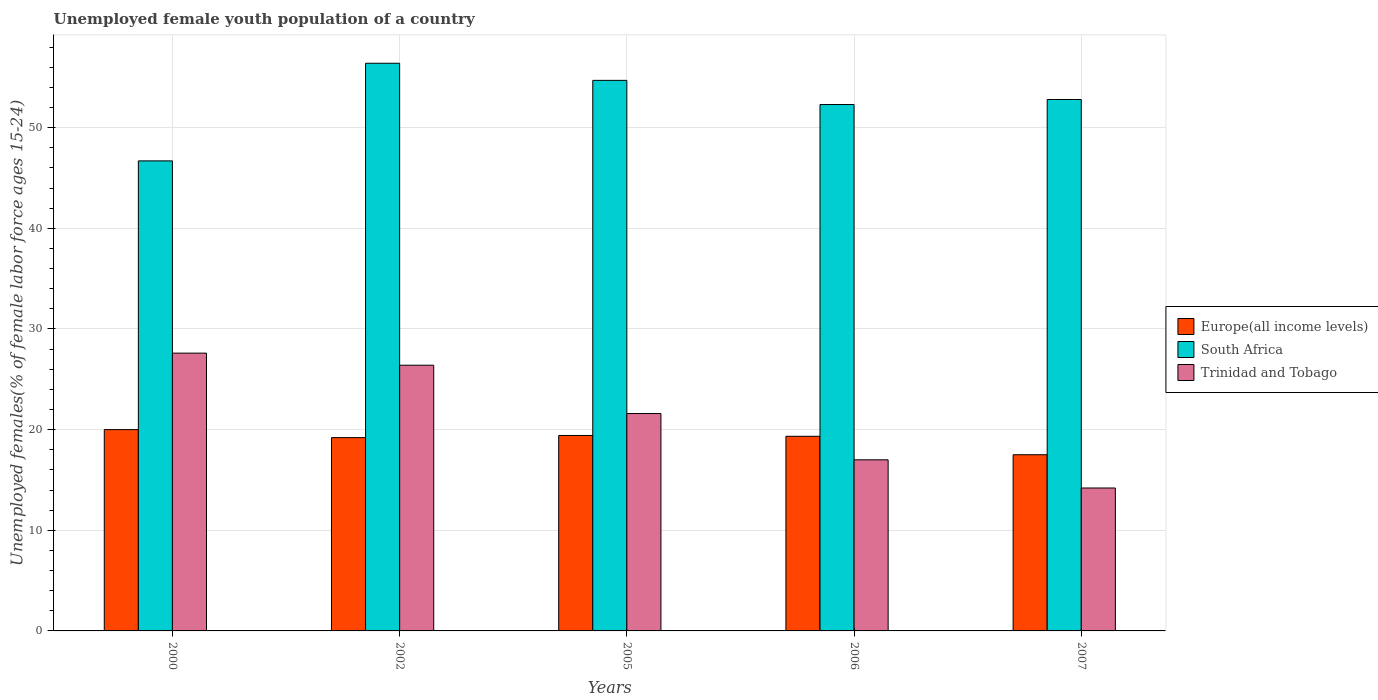What is the label of the 4th group of bars from the left?
Your answer should be compact. 2006. In how many cases, is the number of bars for a given year not equal to the number of legend labels?
Ensure brevity in your answer.  0. What is the percentage of unemployed female youth population in Trinidad and Tobago in 2000?
Keep it short and to the point. 27.6. Across all years, what is the maximum percentage of unemployed female youth population in Trinidad and Tobago?
Keep it short and to the point. 27.6. Across all years, what is the minimum percentage of unemployed female youth population in South Africa?
Offer a terse response. 46.7. In which year was the percentage of unemployed female youth population in Trinidad and Tobago maximum?
Your response must be concise. 2000. In which year was the percentage of unemployed female youth population in Trinidad and Tobago minimum?
Your response must be concise. 2007. What is the total percentage of unemployed female youth population in Trinidad and Tobago in the graph?
Provide a short and direct response. 106.8. What is the difference between the percentage of unemployed female youth population in South Africa in 2000 and that in 2007?
Provide a succinct answer. -6.1. What is the difference between the percentage of unemployed female youth population in South Africa in 2000 and the percentage of unemployed female youth population in Trinidad and Tobago in 2002?
Offer a very short reply. 20.3. What is the average percentage of unemployed female youth population in South Africa per year?
Give a very brief answer. 52.58. In the year 2005, what is the difference between the percentage of unemployed female youth population in Europe(all income levels) and percentage of unemployed female youth population in South Africa?
Give a very brief answer. -35.28. In how many years, is the percentage of unemployed female youth population in Europe(all income levels) greater than 54 %?
Your response must be concise. 0. What is the ratio of the percentage of unemployed female youth population in Europe(all income levels) in 2005 to that in 2006?
Keep it short and to the point. 1. Is the percentage of unemployed female youth population in South Africa in 2002 less than that in 2006?
Make the answer very short. No. What is the difference between the highest and the second highest percentage of unemployed female youth population in South Africa?
Make the answer very short. 1.7. What is the difference between the highest and the lowest percentage of unemployed female youth population in Trinidad and Tobago?
Give a very brief answer. 13.4. In how many years, is the percentage of unemployed female youth population in South Africa greater than the average percentage of unemployed female youth population in South Africa taken over all years?
Your answer should be very brief. 3. Is the sum of the percentage of unemployed female youth population in Trinidad and Tobago in 2000 and 2002 greater than the maximum percentage of unemployed female youth population in South Africa across all years?
Your answer should be very brief. No. What does the 1st bar from the left in 2007 represents?
Provide a short and direct response. Europe(all income levels). What does the 3rd bar from the right in 2007 represents?
Ensure brevity in your answer.  Europe(all income levels). Is it the case that in every year, the sum of the percentage of unemployed female youth population in Trinidad and Tobago and percentage of unemployed female youth population in Europe(all income levels) is greater than the percentage of unemployed female youth population in South Africa?
Keep it short and to the point. No. How many bars are there?
Ensure brevity in your answer.  15. What is the difference between two consecutive major ticks on the Y-axis?
Provide a short and direct response. 10. Are the values on the major ticks of Y-axis written in scientific E-notation?
Keep it short and to the point. No. Does the graph contain any zero values?
Give a very brief answer. No. Where does the legend appear in the graph?
Provide a succinct answer. Center right. How many legend labels are there?
Your answer should be compact. 3. How are the legend labels stacked?
Provide a short and direct response. Vertical. What is the title of the graph?
Your answer should be compact. Unemployed female youth population of a country. Does "Uruguay" appear as one of the legend labels in the graph?
Your answer should be compact. No. What is the label or title of the Y-axis?
Your response must be concise. Unemployed females(% of female labor force ages 15-24). What is the Unemployed females(% of female labor force ages 15-24) in Europe(all income levels) in 2000?
Offer a terse response. 20. What is the Unemployed females(% of female labor force ages 15-24) in South Africa in 2000?
Your answer should be very brief. 46.7. What is the Unemployed females(% of female labor force ages 15-24) in Trinidad and Tobago in 2000?
Ensure brevity in your answer.  27.6. What is the Unemployed females(% of female labor force ages 15-24) of Europe(all income levels) in 2002?
Provide a succinct answer. 19.21. What is the Unemployed females(% of female labor force ages 15-24) of South Africa in 2002?
Keep it short and to the point. 56.4. What is the Unemployed females(% of female labor force ages 15-24) in Trinidad and Tobago in 2002?
Offer a terse response. 26.4. What is the Unemployed females(% of female labor force ages 15-24) of Europe(all income levels) in 2005?
Give a very brief answer. 19.42. What is the Unemployed females(% of female labor force ages 15-24) of South Africa in 2005?
Your answer should be compact. 54.7. What is the Unemployed females(% of female labor force ages 15-24) of Trinidad and Tobago in 2005?
Make the answer very short. 21.6. What is the Unemployed females(% of female labor force ages 15-24) of Europe(all income levels) in 2006?
Offer a terse response. 19.34. What is the Unemployed females(% of female labor force ages 15-24) of South Africa in 2006?
Your answer should be compact. 52.3. What is the Unemployed females(% of female labor force ages 15-24) in Europe(all income levels) in 2007?
Provide a succinct answer. 17.5. What is the Unemployed females(% of female labor force ages 15-24) of South Africa in 2007?
Ensure brevity in your answer.  52.8. What is the Unemployed females(% of female labor force ages 15-24) of Trinidad and Tobago in 2007?
Provide a short and direct response. 14.2. Across all years, what is the maximum Unemployed females(% of female labor force ages 15-24) of Europe(all income levels)?
Offer a very short reply. 20. Across all years, what is the maximum Unemployed females(% of female labor force ages 15-24) in South Africa?
Provide a succinct answer. 56.4. Across all years, what is the maximum Unemployed females(% of female labor force ages 15-24) of Trinidad and Tobago?
Keep it short and to the point. 27.6. Across all years, what is the minimum Unemployed females(% of female labor force ages 15-24) of Europe(all income levels)?
Make the answer very short. 17.5. Across all years, what is the minimum Unemployed females(% of female labor force ages 15-24) of South Africa?
Keep it short and to the point. 46.7. Across all years, what is the minimum Unemployed females(% of female labor force ages 15-24) in Trinidad and Tobago?
Your answer should be very brief. 14.2. What is the total Unemployed females(% of female labor force ages 15-24) in Europe(all income levels) in the graph?
Make the answer very short. 95.47. What is the total Unemployed females(% of female labor force ages 15-24) of South Africa in the graph?
Provide a succinct answer. 262.9. What is the total Unemployed females(% of female labor force ages 15-24) in Trinidad and Tobago in the graph?
Your answer should be compact. 106.8. What is the difference between the Unemployed females(% of female labor force ages 15-24) in Europe(all income levels) in 2000 and that in 2002?
Provide a succinct answer. 0.8. What is the difference between the Unemployed females(% of female labor force ages 15-24) in South Africa in 2000 and that in 2002?
Provide a succinct answer. -9.7. What is the difference between the Unemployed females(% of female labor force ages 15-24) in Europe(all income levels) in 2000 and that in 2005?
Your answer should be very brief. 0.58. What is the difference between the Unemployed females(% of female labor force ages 15-24) in South Africa in 2000 and that in 2005?
Your response must be concise. -8. What is the difference between the Unemployed females(% of female labor force ages 15-24) in Europe(all income levels) in 2000 and that in 2006?
Offer a very short reply. 0.66. What is the difference between the Unemployed females(% of female labor force ages 15-24) of Trinidad and Tobago in 2000 and that in 2006?
Give a very brief answer. 10.6. What is the difference between the Unemployed females(% of female labor force ages 15-24) in Europe(all income levels) in 2000 and that in 2007?
Your answer should be compact. 2.5. What is the difference between the Unemployed females(% of female labor force ages 15-24) of South Africa in 2000 and that in 2007?
Ensure brevity in your answer.  -6.1. What is the difference between the Unemployed females(% of female labor force ages 15-24) in Europe(all income levels) in 2002 and that in 2005?
Provide a succinct answer. -0.21. What is the difference between the Unemployed females(% of female labor force ages 15-24) in South Africa in 2002 and that in 2005?
Give a very brief answer. 1.7. What is the difference between the Unemployed females(% of female labor force ages 15-24) in Trinidad and Tobago in 2002 and that in 2005?
Provide a succinct answer. 4.8. What is the difference between the Unemployed females(% of female labor force ages 15-24) in Europe(all income levels) in 2002 and that in 2006?
Offer a very short reply. -0.13. What is the difference between the Unemployed females(% of female labor force ages 15-24) in Trinidad and Tobago in 2002 and that in 2006?
Provide a succinct answer. 9.4. What is the difference between the Unemployed females(% of female labor force ages 15-24) of Europe(all income levels) in 2002 and that in 2007?
Make the answer very short. 1.7. What is the difference between the Unemployed females(% of female labor force ages 15-24) in Trinidad and Tobago in 2002 and that in 2007?
Keep it short and to the point. 12.2. What is the difference between the Unemployed females(% of female labor force ages 15-24) of Europe(all income levels) in 2005 and that in 2006?
Offer a very short reply. 0.08. What is the difference between the Unemployed females(% of female labor force ages 15-24) in Europe(all income levels) in 2005 and that in 2007?
Offer a terse response. 1.92. What is the difference between the Unemployed females(% of female labor force ages 15-24) in South Africa in 2005 and that in 2007?
Your answer should be compact. 1.9. What is the difference between the Unemployed females(% of female labor force ages 15-24) in Trinidad and Tobago in 2005 and that in 2007?
Give a very brief answer. 7.4. What is the difference between the Unemployed females(% of female labor force ages 15-24) of Europe(all income levels) in 2006 and that in 2007?
Make the answer very short. 1.83. What is the difference between the Unemployed females(% of female labor force ages 15-24) of South Africa in 2006 and that in 2007?
Give a very brief answer. -0.5. What is the difference between the Unemployed females(% of female labor force ages 15-24) of Europe(all income levels) in 2000 and the Unemployed females(% of female labor force ages 15-24) of South Africa in 2002?
Provide a short and direct response. -36.4. What is the difference between the Unemployed females(% of female labor force ages 15-24) in Europe(all income levels) in 2000 and the Unemployed females(% of female labor force ages 15-24) in Trinidad and Tobago in 2002?
Your answer should be compact. -6.4. What is the difference between the Unemployed females(% of female labor force ages 15-24) of South Africa in 2000 and the Unemployed females(% of female labor force ages 15-24) of Trinidad and Tobago in 2002?
Give a very brief answer. 20.3. What is the difference between the Unemployed females(% of female labor force ages 15-24) of Europe(all income levels) in 2000 and the Unemployed females(% of female labor force ages 15-24) of South Africa in 2005?
Offer a very short reply. -34.7. What is the difference between the Unemployed females(% of female labor force ages 15-24) in Europe(all income levels) in 2000 and the Unemployed females(% of female labor force ages 15-24) in Trinidad and Tobago in 2005?
Your response must be concise. -1.6. What is the difference between the Unemployed females(% of female labor force ages 15-24) in South Africa in 2000 and the Unemployed females(% of female labor force ages 15-24) in Trinidad and Tobago in 2005?
Offer a terse response. 25.1. What is the difference between the Unemployed females(% of female labor force ages 15-24) of Europe(all income levels) in 2000 and the Unemployed females(% of female labor force ages 15-24) of South Africa in 2006?
Make the answer very short. -32.3. What is the difference between the Unemployed females(% of female labor force ages 15-24) in Europe(all income levels) in 2000 and the Unemployed females(% of female labor force ages 15-24) in Trinidad and Tobago in 2006?
Provide a short and direct response. 3. What is the difference between the Unemployed females(% of female labor force ages 15-24) in South Africa in 2000 and the Unemployed females(% of female labor force ages 15-24) in Trinidad and Tobago in 2006?
Offer a terse response. 29.7. What is the difference between the Unemployed females(% of female labor force ages 15-24) in Europe(all income levels) in 2000 and the Unemployed females(% of female labor force ages 15-24) in South Africa in 2007?
Make the answer very short. -32.8. What is the difference between the Unemployed females(% of female labor force ages 15-24) in Europe(all income levels) in 2000 and the Unemployed females(% of female labor force ages 15-24) in Trinidad and Tobago in 2007?
Your answer should be very brief. 5.8. What is the difference between the Unemployed females(% of female labor force ages 15-24) of South Africa in 2000 and the Unemployed females(% of female labor force ages 15-24) of Trinidad and Tobago in 2007?
Your response must be concise. 32.5. What is the difference between the Unemployed females(% of female labor force ages 15-24) of Europe(all income levels) in 2002 and the Unemployed females(% of female labor force ages 15-24) of South Africa in 2005?
Keep it short and to the point. -35.49. What is the difference between the Unemployed females(% of female labor force ages 15-24) of Europe(all income levels) in 2002 and the Unemployed females(% of female labor force ages 15-24) of Trinidad and Tobago in 2005?
Your response must be concise. -2.39. What is the difference between the Unemployed females(% of female labor force ages 15-24) of South Africa in 2002 and the Unemployed females(% of female labor force ages 15-24) of Trinidad and Tobago in 2005?
Make the answer very short. 34.8. What is the difference between the Unemployed females(% of female labor force ages 15-24) of Europe(all income levels) in 2002 and the Unemployed females(% of female labor force ages 15-24) of South Africa in 2006?
Ensure brevity in your answer.  -33.09. What is the difference between the Unemployed females(% of female labor force ages 15-24) of Europe(all income levels) in 2002 and the Unemployed females(% of female labor force ages 15-24) of Trinidad and Tobago in 2006?
Your answer should be compact. 2.21. What is the difference between the Unemployed females(% of female labor force ages 15-24) in South Africa in 2002 and the Unemployed females(% of female labor force ages 15-24) in Trinidad and Tobago in 2006?
Make the answer very short. 39.4. What is the difference between the Unemployed females(% of female labor force ages 15-24) in Europe(all income levels) in 2002 and the Unemployed females(% of female labor force ages 15-24) in South Africa in 2007?
Provide a short and direct response. -33.59. What is the difference between the Unemployed females(% of female labor force ages 15-24) of Europe(all income levels) in 2002 and the Unemployed females(% of female labor force ages 15-24) of Trinidad and Tobago in 2007?
Your response must be concise. 5.01. What is the difference between the Unemployed females(% of female labor force ages 15-24) in South Africa in 2002 and the Unemployed females(% of female labor force ages 15-24) in Trinidad and Tobago in 2007?
Provide a succinct answer. 42.2. What is the difference between the Unemployed females(% of female labor force ages 15-24) in Europe(all income levels) in 2005 and the Unemployed females(% of female labor force ages 15-24) in South Africa in 2006?
Your answer should be compact. -32.88. What is the difference between the Unemployed females(% of female labor force ages 15-24) in Europe(all income levels) in 2005 and the Unemployed females(% of female labor force ages 15-24) in Trinidad and Tobago in 2006?
Your answer should be very brief. 2.42. What is the difference between the Unemployed females(% of female labor force ages 15-24) of South Africa in 2005 and the Unemployed females(% of female labor force ages 15-24) of Trinidad and Tobago in 2006?
Offer a very short reply. 37.7. What is the difference between the Unemployed females(% of female labor force ages 15-24) of Europe(all income levels) in 2005 and the Unemployed females(% of female labor force ages 15-24) of South Africa in 2007?
Your answer should be compact. -33.38. What is the difference between the Unemployed females(% of female labor force ages 15-24) in Europe(all income levels) in 2005 and the Unemployed females(% of female labor force ages 15-24) in Trinidad and Tobago in 2007?
Your answer should be compact. 5.22. What is the difference between the Unemployed females(% of female labor force ages 15-24) of South Africa in 2005 and the Unemployed females(% of female labor force ages 15-24) of Trinidad and Tobago in 2007?
Make the answer very short. 40.5. What is the difference between the Unemployed females(% of female labor force ages 15-24) of Europe(all income levels) in 2006 and the Unemployed females(% of female labor force ages 15-24) of South Africa in 2007?
Your response must be concise. -33.46. What is the difference between the Unemployed females(% of female labor force ages 15-24) in Europe(all income levels) in 2006 and the Unemployed females(% of female labor force ages 15-24) in Trinidad and Tobago in 2007?
Your answer should be compact. 5.14. What is the difference between the Unemployed females(% of female labor force ages 15-24) in South Africa in 2006 and the Unemployed females(% of female labor force ages 15-24) in Trinidad and Tobago in 2007?
Offer a very short reply. 38.1. What is the average Unemployed females(% of female labor force ages 15-24) of Europe(all income levels) per year?
Give a very brief answer. 19.09. What is the average Unemployed females(% of female labor force ages 15-24) in South Africa per year?
Your response must be concise. 52.58. What is the average Unemployed females(% of female labor force ages 15-24) of Trinidad and Tobago per year?
Your answer should be compact. 21.36. In the year 2000, what is the difference between the Unemployed females(% of female labor force ages 15-24) in Europe(all income levels) and Unemployed females(% of female labor force ages 15-24) in South Africa?
Ensure brevity in your answer.  -26.7. In the year 2000, what is the difference between the Unemployed females(% of female labor force ages 15-24) of Europe(all income levels) and Unemployed females(% of female labor force ages 15-24) of Trinidad and Tobago?
Offer a terse response. -7.6. In the year 2002, what is the difference between the Unemployed females(% of female labor force ages 15-24) of Europe(all income levels) and Unemployed females(% of female labor force ages 15-24) of South Africa?
Give a very brief answer. -37.19. In the year 2002, what is the difference between the Unemployed females(% of female labor force ages 15-24) of Europe(all income levels) and Unemployed females(% of female labor force ages 15-24) of Trinidad and Tobago?
Keep it short and to the point. -7.19. In the year 2002, what is the difference between the Unemployed females(% of female labor force ages 15-24) of South Africa and Unemployed females(% of female labor force ages 15-24) of Trinidad and Tobago?
Provide a short and direct response. 30. In the year 2005, what is the difference between the Unemployed females(% of female labor force ages 15-24) in Europe(all income levels) and Unemployed females(% of female labor force ages 15-24) in South Africa?
Offer a terse response. -35.28. In the year 2005, what is the difference between the Unemployed females(% of female labor force ages 15-24) of Europe(all income levels) and Unemployed females(% of female labor force ages 15-24) of Trinidad and Tobago?
Keep it short and to the point. -2.18. In the year 2005, what is the difference between the Unemployed females(% of female labor force ages 15-24) of South Africa and Unemployed females(% of female labor force ages 15-24) of Trinidad and Tobago?
Your answer should be compact. 33.1. In the year 2006, what is the difference between the Unemployed females(% of female labor force ages 15-24) in Europe(all income levels) and Unemployed females(% of female labor force ages 15-24) in South Africa?
Offer a very short reply. -32.96. In the year 2006, what is the difference between the Unemployed females(% of female labor force ages 15-24) of Europe(all income levels) and Unemployed females(% of female labor force ages 15-24) of Trinidad and Tobago?
Keep it short and to the point. 2.34. In the year 2006, what is the difference between the Unemployed females(% of female labor force ages 15-24) of South Africa and Unemployed females(% of female labor force ages 15-24) of Trinidad and Tobago?
Your answer should be compact. 35.3. In the year 2007, what is the difference between the Unemployed females(% of female labor force ages 15-24) of Europe(all income levels) and Unemployed females(% of female labor force ages 15-24) of South Africa?
Your response must be concise. -35.3. In the year 2007, what is the difference between the Unemployed females(% of female labor force ages 15-24) in Europe(all income levels) and Unemployed females(% of female labor force ages 15-24) in Trinidad and Tobago?
Give a very brief answer. 3.3. In the year 2007, what is the difference between the Unemployed females(% of female labor force ages 15-24) of South Africa and Unemployed females(% of female labor force ages 15-24) of Trinidad and Tobago?
Give a very brief answer. 38.6. What is the ratio of the Unemployed females(% of female labor force ages 15-24) of Europe(all income levels) in 2000 to that in 2002?
Your answer should be very brief. 1.04. What is the ratio of the Unemployed females(% of female labor force ages 15-24) in South Africa in 2000 to that in 2002?
Provide a short and direct response. 0.83. What is the ratio of the Unemployed females(% of female labor force ages 15-24) in Trinidad and Tobago in 2000 to that in 2002?
Offer a very short reply. 1.05. What is the ratio of the Unemployed females(% of female labor force ages 15-24) in Europe(all income levels) in 2000 to that in 2005?
Offer a terse response. 1.03. What is the ratio of the Unemployed females(% of female labor force ages 15-24) in South Africa in 2000 to that in 2005?
Your response must be concise. 0.85. What is the ratio of the Unemployed females(% of female labor force ages 15-24) in Trinidad and Tobago in 2000 to that in 2005?
Your answer should be very brief. 1.28. What is the ratio of the Unemployed females(% of female labor force ages 15-24) in Europe(all income levels) in 2000 to that in 2006?
Your answer should be very brief. 1.03. What is the ratio of the Unemployed females(% of female labor force ages 15-24) of South Africa in 2000 to that in 2006?
Ensure brevity in your answer.  0.89. What is the ratio of the Unemployed females(% of female labor force ages 15-24) in Trinidad and Tobago in 2000 to that in 2006?
Your response must be concise. 1.62. What is the ratio of the Unemployed females(% of female labor force ages 15-24) in Europe(all income levels) in 2000 to that in 2007?
Provide a short and direct response. 1.14. What is the ratio of the Unemployed females(% of female labor force ages 15-24) in South Africa in 2000 to that in 2007?
Keep it short and to the point. 0.88. What is the ratio of the Unemployed females(% of female labor force ages 15-24) in Trinidad and Tobago in 2000 to that in 2007?
Ensure brevity in your answer.  1.94. What is the ratio of the Unemployed females(% of female labor force ages 15-24) in Europe(all income levels) in 2002 to that in 2005?
Make the answer very short. 0.99. What is the ratio of the Unemployed females(% of female labor force ages 15-24) in South Africa in 2002 to that in 2005?
Ensure brevity in your answer.  1.03. What is the ratio of the Unemployed females(% of female labor force ages 15-24) in Trinidad and Tobago in 2002 to that in 2005?
Make the answer very short. 1.22. What is the ratio of the Unemployed females(% of female labor force ages 15-24) of Europe(all income levels) in 2002 to that in 2006?
Make the answer very short. 0.99. What is the ratio of the Unemployed females(% of female labor force ages 15-24) in South Africa in 2002 to that in 2006?
Provide a succinct answer. 1.08. What is the ratio of the Unemployed females(% of female labor force ages 15-24) in Trinidad and Tobago in 2002 to that in 2006?
Give a very brief answer. 1.55. What is the ratio of the Unemployed females(% of female labor force ages 15-24) in Europe(all income levels) in 2002 to that in 2007?
Ensure brevity in your answer.  1.1. What is the ratio of the Unemployed females(% of female labor force ages 15-24) of South Africa in 2002 to that in 2007?
Keep it short and to the point. 1.07. What is the ratio of the Unemployed females(% of female labor force ages 15-24) in Trinidad and Tobago in 2002 to that in 2007?
Give a very brief answer. 1.86. What is the ratio of the Unemployed females(% of female labor force ages 15-24) of South Africa in 2005 to that in 2006?
Offer a terse response. 1.05. What is the ratio of the Unemployed females(% of female labor force ages 15-24) of Trinidad and Tobago in 2005 to that in 2006?
Provide a short and direct response. 1.27. What is the ratio of the Unemployed females(% of female labor force ages 15-24) of Europe(all income levels) in 2005 to that in 2007?
Offer a very short reply. 1.11. What is the ratio of the Unemployed females(% of female labor force ages 15-24) in South Africa in 2005 to that in 2007?
Offer a terse response. 1.04. What is the ratio of the Unemployed females(% of female labor force ages 15-24) of Trinidad and Tobago in 2005 to that in 2007?
Make the answer very short. 1.52. What is the ratio of the Unemployed females(% of female labor force ages 15-24) of Europe(all income levels) in 2006 to that in 2007?
Keep it short and to the point. 1.1. What is the ratio of the Unemployed females(% of female labor force ages 15-24) in Trinidad and Tobago in 2006 to that in 2007?
Give a very brief answer. 1.2. What is the difference between the highest and the second highest Unemployed females(% of female labor force ages 15-24) in Europe(all income levels)?
Make the answer very short. 0.58. What is the difference between the highest and the second highest Unemployed females(% of female labor force ages 15-24) of Trinidad and Tobago?
Provide a succinct answer. 1.2. What is the difference between the highest and the lowest Unemployed females(% of female labor force ages 15-24) of Europe(all income levels)?
Your response must be concise. 2.5. 